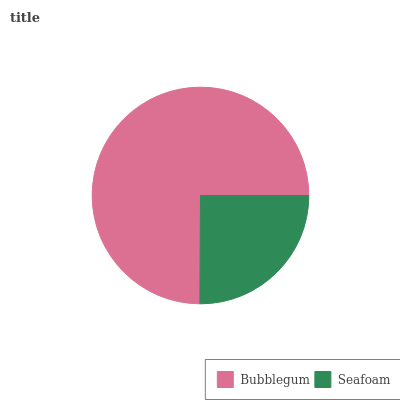Is Seafoam the minimum?
Answer yes or no. Yes. Is Bubblegum the maximum?
Answer yes or no. Yes. Is Seafoam the maximum?
Answer yes or no. No. Is Bubblegum greater than Seafoam?
Answer yes or no. Yes. Is Seafoam less than Bubblegum?
Answer yes or no. Yes. Is Seafoam greater than Bubblegum?
Answer yes or no. No. Is Bubblegum less than Seafoam?
Answer yes or no. No. Is Bubblegum the high median?
Answer yes or no. Yes. Is Seafoam the low median?
Answer yes or no. Yes. Is Seafoam the high median?
Answer yes or no. No. Is Bubblegum the low median?
Answer yes or no. No. 